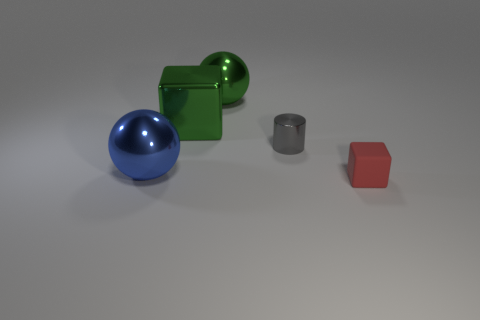What is the texture of the objects? The objects have different textures. The blue sphere and the green cube seem to have a shiny, reflective surface that suggests they're made of a material like polished metal or plastic. The gray cylinder and red cube appear to have matte surfaces, indicating a less reflective material. 